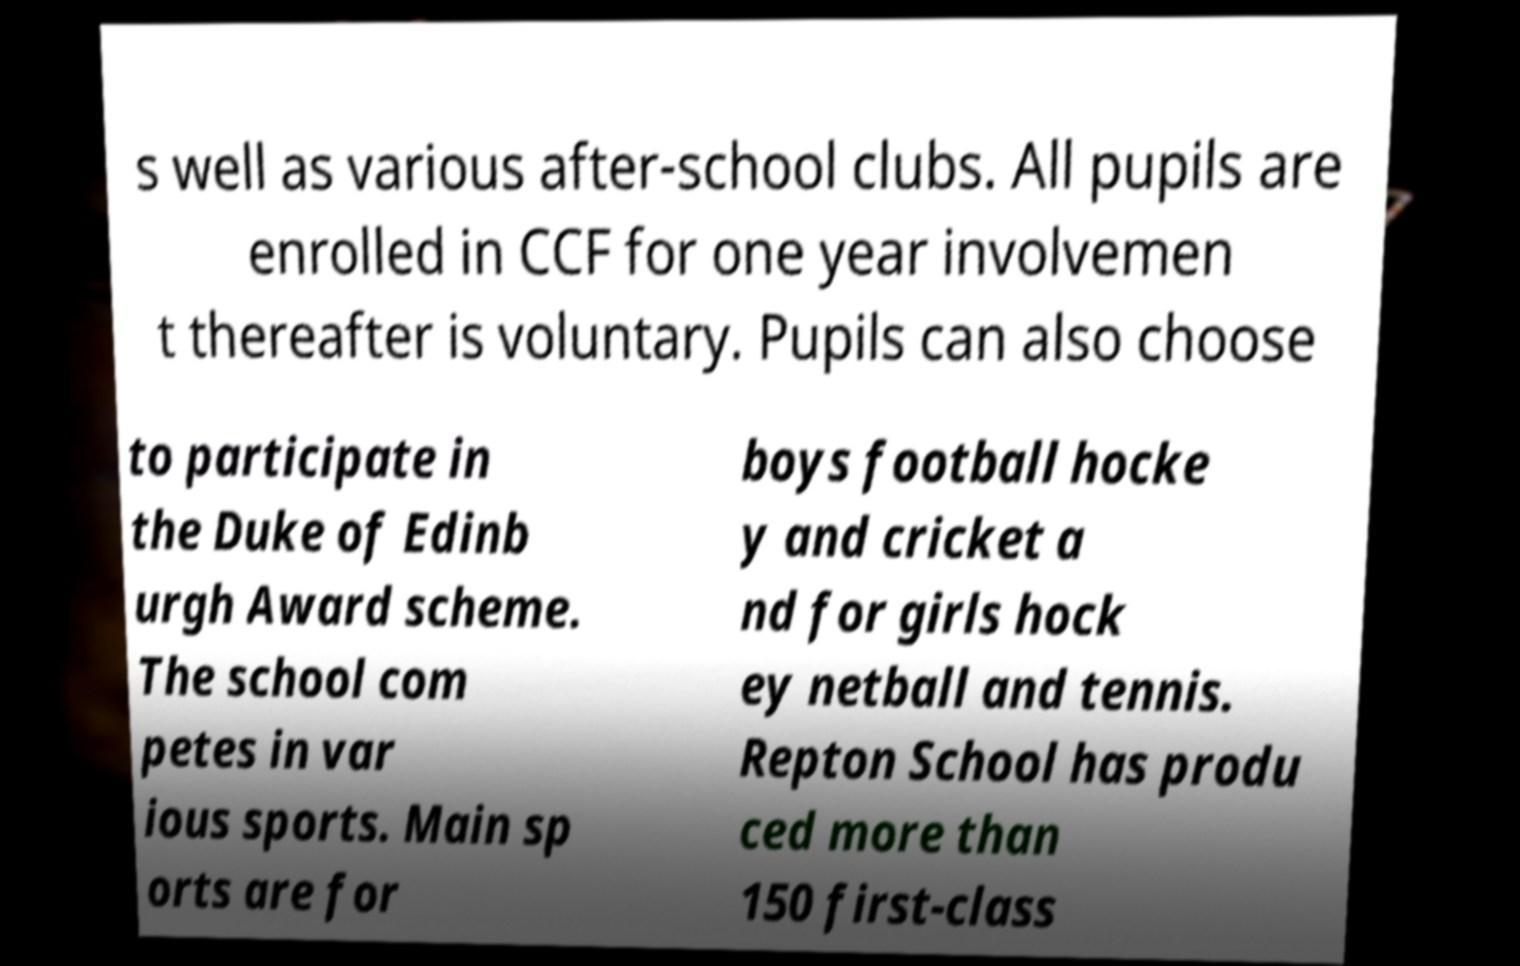Could you extract and type out the text from this image? s well as various after-school clubs. All pupils are enrolled in CCF for one year involvemen t thereafter is voluntary. Pupils can also choose to participate in the Duke of Edinb urgh Award scheme. The school com petes in var ious sports. Main sp orts are for boys football hocke y and cricket a nd for girls hock ey netball and tennis. Repton School has produ ced more than 150 first-class 